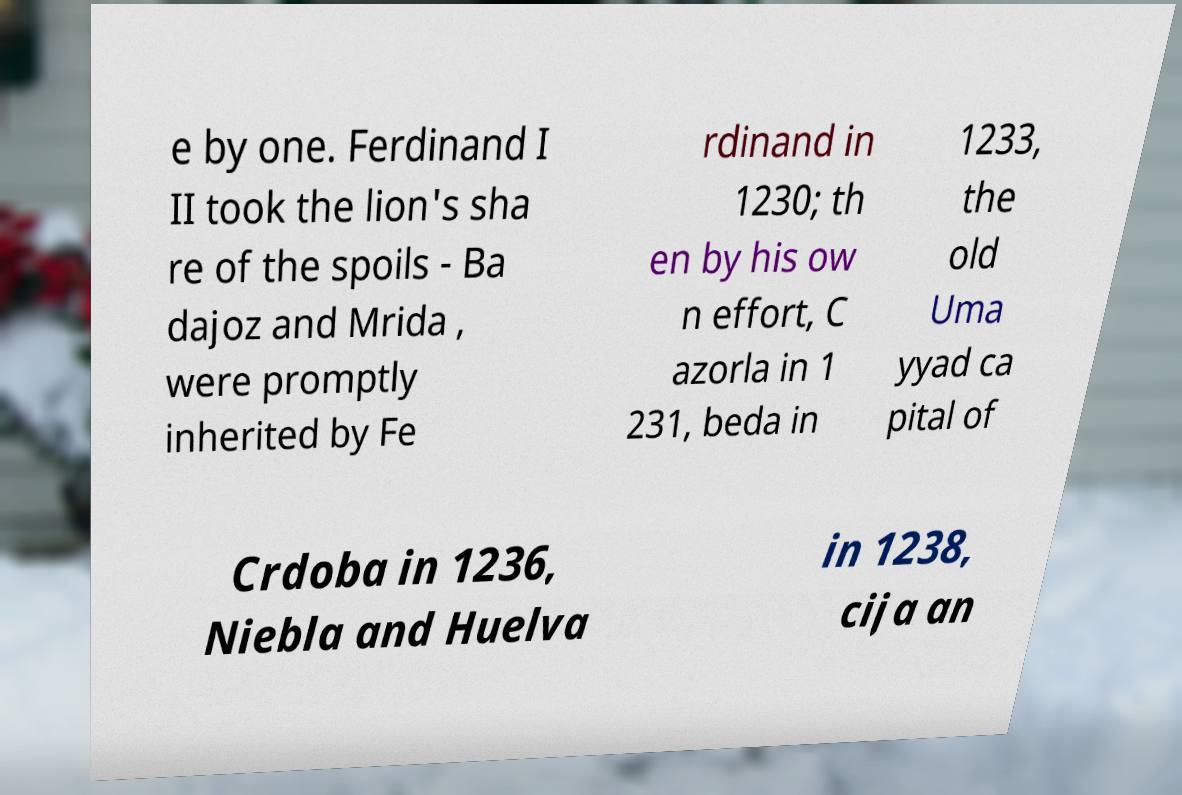For documentation purposes, I need the text within this image transcribed. Could you provide that? e by one. Ferdinand I II took the lion's sha re of the spoils - Ba dajoz and Mrida , were promptly inherited by Fe rdinand in 1230; th en by his ow n effort, C azorla in 1 231, beda in 1233, the old Uma yyad ca pital of Crdoba in 1236, Niebla and Huelva in 1238, cija an 